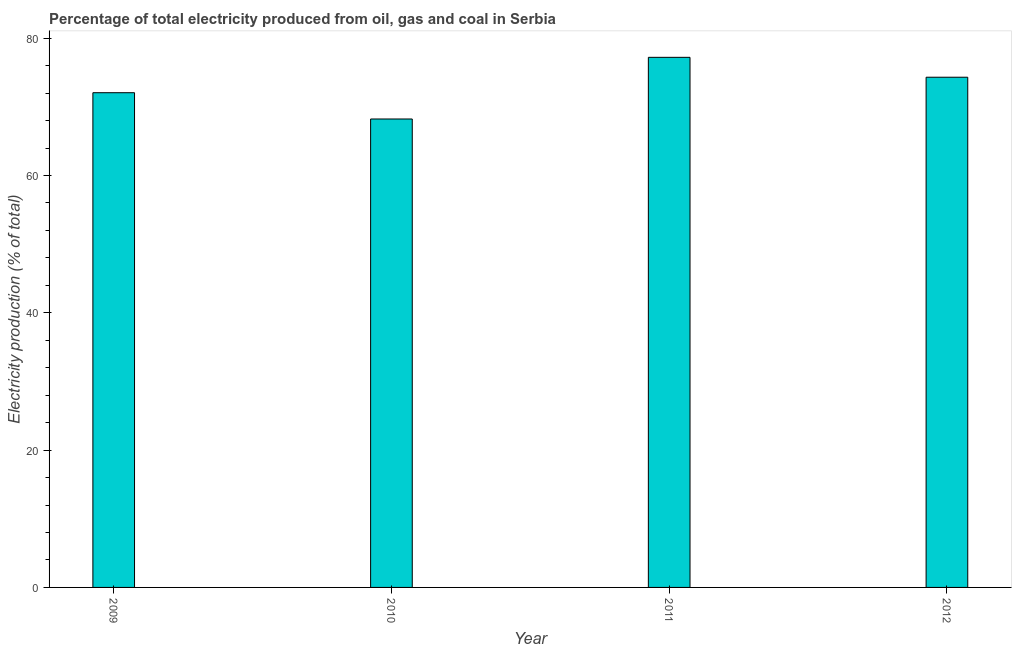Does the graph contain any zero values?
Keep it short and to the point. No. Does the graph contain grids?
Your answer should be very brief. No. What is the title of the graph?
Offer a terse response. Percentage of total electricity produced from oil, gas and coal in Serbia. What is the label or title of the X-axis?
Provide a succinct answer. Year. What is the label or title of the Y-axis?
Offer a very short reply. Electricity production (% of total). What is the electricity production in 2010?
Make the answer very short. 68.23. Across all years, what is the maximum electricity production?
Provide a short and direct response. 77.21. Across all years, what is the minimum electricity production?
Your response must be concise. 68.23. In which year was the electricity production minimum?
Your response must be concise. 2010. What is the sum of the electricity production?
Your response must be concise. 291.79. What is the difference between the electricity production in 2009 and 2012?
Offer a terse response. -2.25. What is the average electricity production per year?
Your response must be concise. 72.95. What is the median electricity production?
Your answer should be very brief. 73.18. In how many years, is the electricity production greater than 72 %?
Give a very brief answer. 3. What is the ratio of the electricity production in 2009 to that in 2010?
Ensure brevity in your answer.  1.06. Is the electricity production in 2011 less than that in 2012?
Your answer should be very brief. No. What is the difference between the highest and the second highest electricity production?
Provide a succinct answer. 2.9. Is the sum of the electricity production in 2009 and 2011 greater than the maximum electricity production across all years?
Ensure brevity in your answer.  Yes. What is the difference between the highest and the lowest electricity production?
Make the answer very short. 8.98. In how many years, is the electricity production greater than the average electricity production taken over all years?
Provide a short and direct response. 2. Are all the bars in the graph horizontal?
Provide a short and direct response. No. What is the difference between two consecutive major ticks on the Y-axis?
Your answer should be compact. 20. Are the values on the major ticks of Y-axis written in scientific E-notation?
Offer a terse response. No. What is the Electricity production (% of total) in 2009?
Your answer should be very brief. 72.05. What is the Electricity production (% of total) of 2010?
Provide a succinct answer. 68.23. What is the Electricity production (% of total) of 2011?
Your answer should be compact. 77.21. What is the Electricity production (% of total) of 2012?
Provide a succinct answer. 74.31. What is the difference between the Electricity production (% of total) in 2009 and 2010?
Keep it short and to the point. 3.83. What is the difference between the Electricity production (% of total) in 2009 and 2011?
Offer a very short reply. -5.15. What is the difference between the Electricity production (% of total) in 2009 and 2012?
Provide a short and direct response. -2.25. What is the difference between the Electricity production (% of total) in 2010 and 2011?
Give a very brief answer. -8.98. What is the difference between the Electricity production (% of total) in 2010 and 2012?
Keep it short and to the point. -6.08. What is the difference between the Electricity production (% of total) in 2011 and 2012?
Keep it short and to the point. 2.9. What is the ratio of the Electricity production (% of total) in 2009 to that in 2010?
Keep it short and to the point. 1.06. What is the ratio of the Electricity production (% of total) in 2009 to that in 2011?
Your answer should be very brief. 0.93. What is the ratio of the Electricity production (% of total) in 2009 to that in 2012?
Your response must be concise. 0.97. What is the ratio of the Electricity production (% of total) in 2010 to that in 2011?
Offer a terse response. 0.88. What is the ratio of the Electricity production (% of total) in 2010 to that in 2012?
Your answer should be very brief. 0.92. What is the ratio of the Electricity production (% of total) in 2011 to that in 2012?
Offer a terse response. 1.04. 